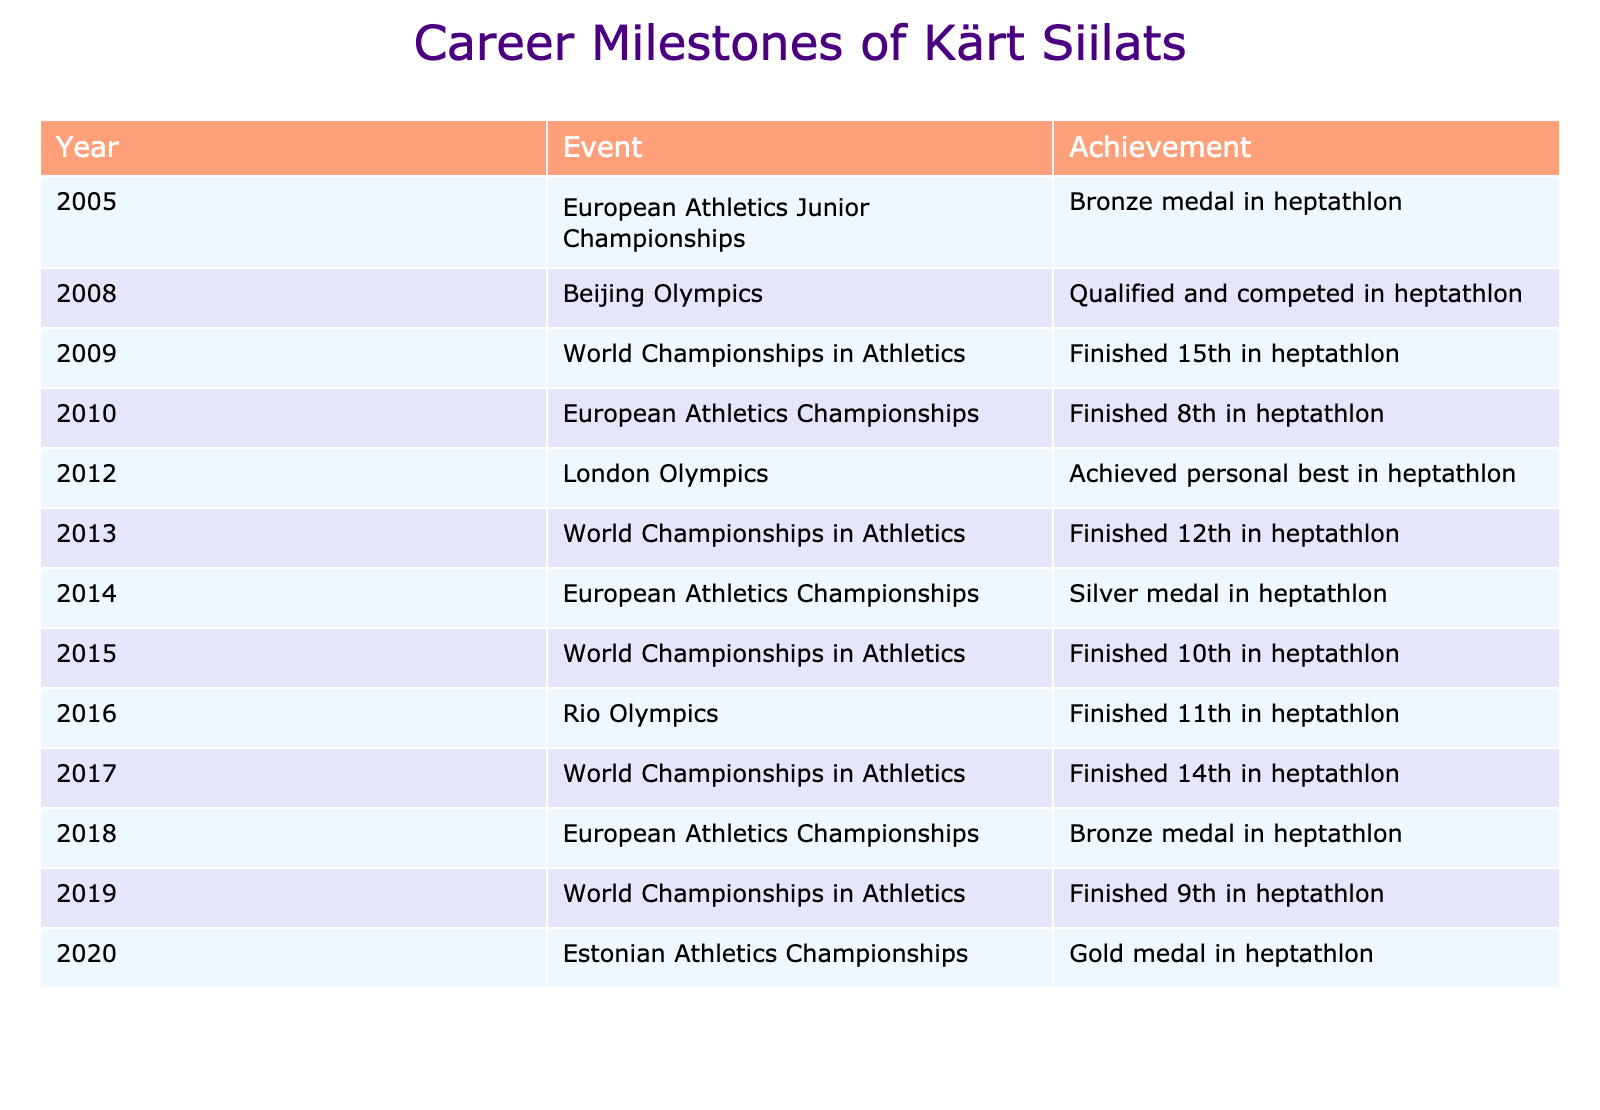What medal did Kärt Siilats win at the 2014 European Athletics Championships? According to the table, Kärt Siilats won a silver medal in heptathlon at the 2014 European Athletics Championships.
Answer: Silver medal In what year did Kärt Siilats achieve her personal best in heptathlon? The table indicates that Kärt Siilats achieved her personal best in heptathlon in 2012 during the London Olympics.
Answer: 2012 How many times did Kärt Siilats finish in the top 10 at the World Championships in Athletics? By filtering the table, we can see that Kärt Siilats finished in the top 10 (positions 1-10) at the World Championships in 2015 (10th place) and 2019 (9th place). Therefore, she finished in the top 10 twice.
Answer: 2 Did Kärt Siilats compete in the heptathlon at the Beijing Olympics? The table states that she qualified and competed in the heptathlon at the 2008 Beijing Olympics. Therefore, the answer is yes.
Answer: Yes What is the total number of medals Kärt Siilats won in European Championships? From the table, Kärt Siilats won medals at the European Championships in 2014 (silver) and 2018 (bronze). Adding these gives a total of 2 medals.
Answer: 2 What position did Kärt Siilats finish in the heptathlon at the Rio Olympics? According to the table, she finished 11th in the heptathlon at the Rio Olympics in 2016.
Answer: 11th How many years passed between Kärt Siilats' bronze medal at the European Athletics Junior Championships and her gold medal at the Estonian Athletics Championships? The bronze medal was won in 2005, and the gold medal was in 2020. The number of years between these two events is 2020 - 2005 = 15 years.
Answer: 15 years How many times did Kärt Siilats participate in the Olympics throughout her career? The table lists her participation in the Olympics in the years 2008, 2012, and 2016, which totals 3 times.
Answer: 3 times Which year did Kärt Siilats have the highest distinction in terms of medal achievement in the table? The highest distinction in the table based on medal color is silver in the 2014 European Championships; therefore, that is her most distinguished achievement listed.
Answer: 2014 